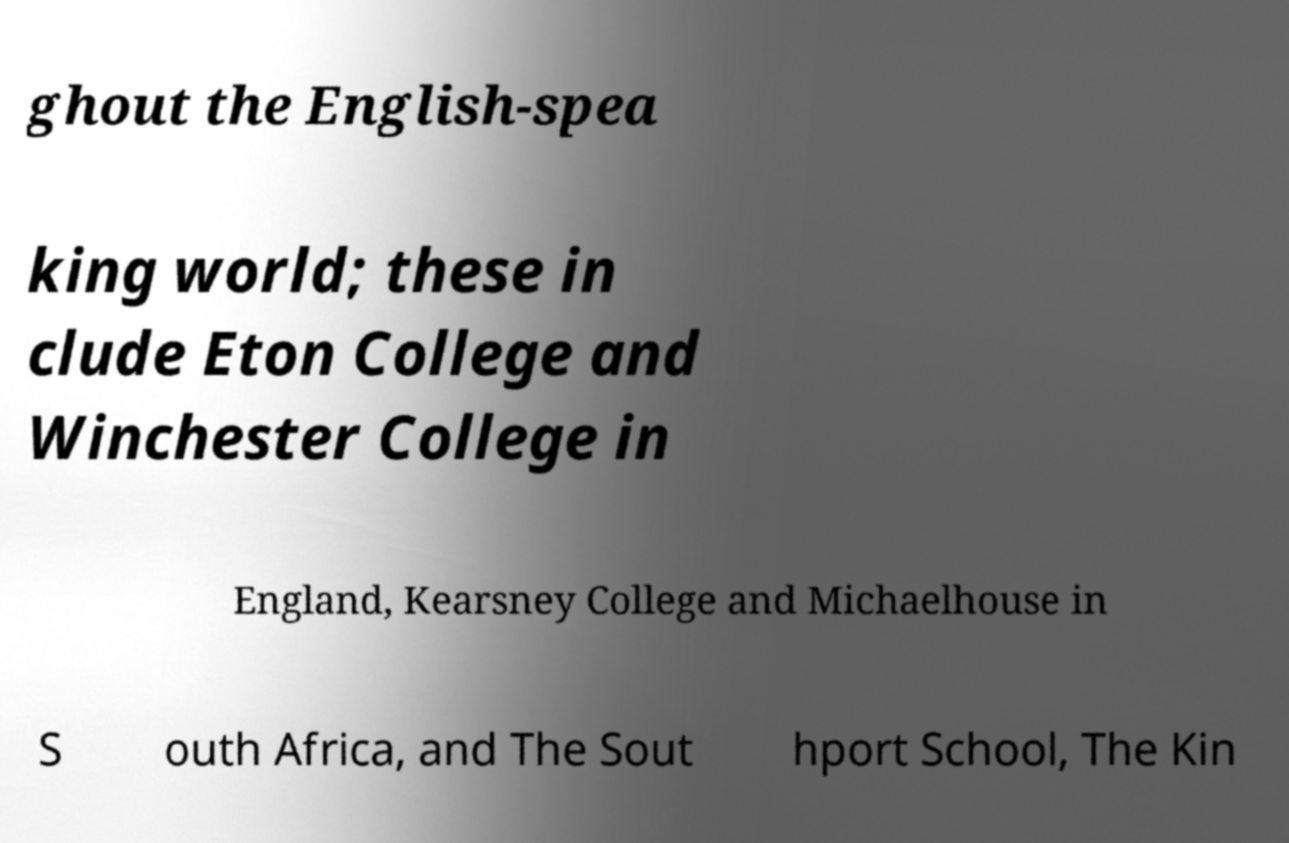Could you extract and type out the text from this image? ghout the English-spea king world; these in clude Eton College and Winchester College in England, Kearsney College and Michaelhouse in S outh Africa, and The Sout hport School, The Kin 